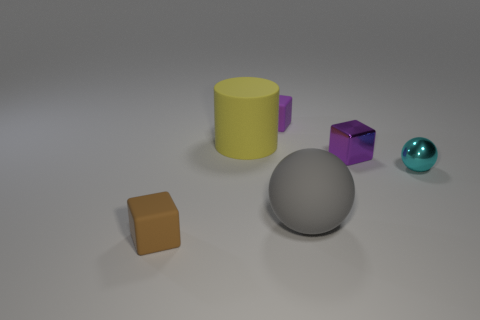There is a cyan thing; does it have the same shape as the tiny brown object left of the purple matte thing?
Your answer should be very brief. No. There is a small cyan shiny ball; are there any big objects behind it?
Your answer should be very brief. Yes. How many gray shiny things have the same shape as the tiny brown thing?
Provide a short and direct response. 0. Is the large yellow cylinder made of the same material as the tiny purple block in front of the cylinder?
Ensure brevity in your answer.  No. What number of gray matte things are there?
Offer a terse response. 1. There is a cube in front of the large gray matte ball; what size is it?
Keep it short and to the point. Small. What number of cyan metal things are the same size as the purple matte thing?
Ensure brevity in your answer.  1. There is a thing that is both behind the big ball and in front of the purple shiny object; what material is it made of?
Ensure brevity in your answer.  Metal. There is a brown cube that is the same size as the cyan metal sphere; what is it made of?
Offer a terse response. Rubber. How big is the cyan metallic ball behind the large thing that is to the right of the rubber object behind the large cylinder?
Make the answer very short. Small. 